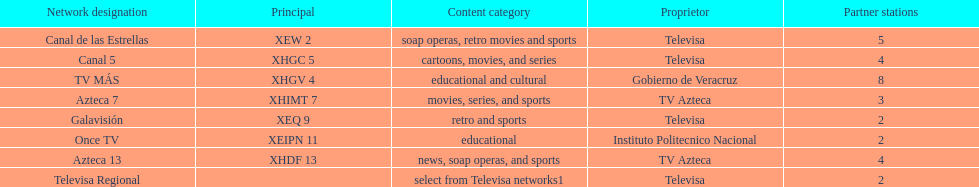What is the number of affiliates of canal de las estrellas. 5. 